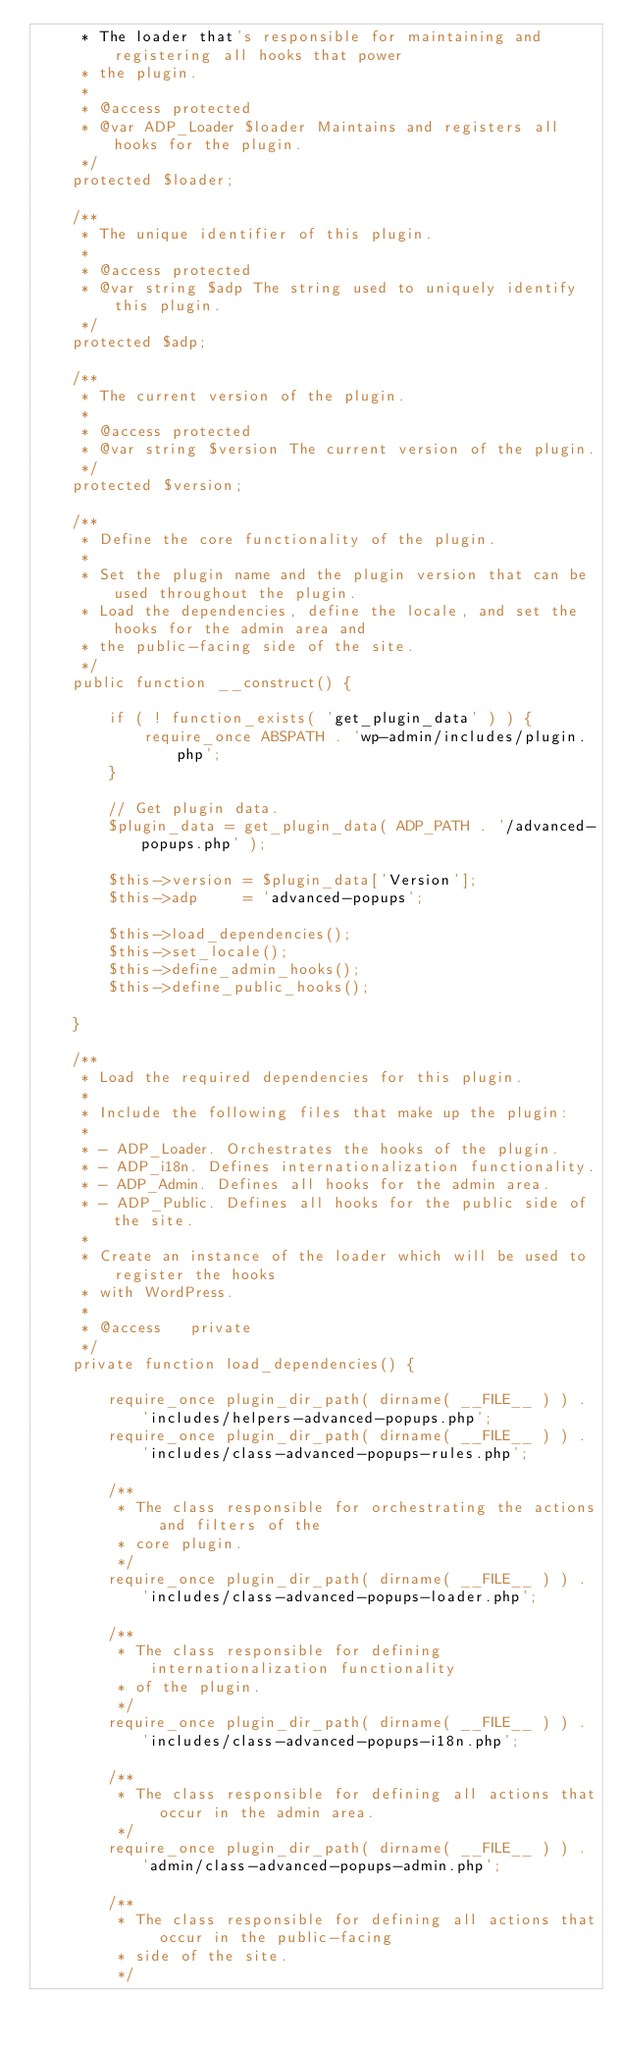Convert code to text. <code><loc_0><loc_0><loc_500><loc_500><_PHP_>	 * The loader that's responsible for maintaining and registering all hooks that power
	 * the plugin.
	 *
	 * @access protected
	 * @var ADP_Loader $loader Maintains and registers all hooks for the plugin.
	 */
	protected $loader;

	/**
	 * The unique identifier of this plugin.
	 *
	 * @access protected
	 * @var string $adp The string used to uniquely identify this plugin.
	 */
	protected $adp;

	/**
	 * The current version of the plugin.
	 *
	 * @access protected
	 * @var string $version The current version of the plugin.
	 */
	protected $version;

	/**
	 * Define the core functionality of the plugin.
	 *
	 * Set the plugin name and the plugin version that can be used throughout the plugin.
	 * Load the dependencies, define the locale, and set the hooks for the admin area and
	 * the public-facing side of the site.
	 */
	public function __construct() {

		if ( ! function_exists( 'get_plugin_data' ) ) {
			require_once ABSPATH . 'wp-admin/includes/plugin.php';
		}

		// Get plugin data.
		$plugin_data = get_plugin_data( ADP_PATH . '/advanced-popups.php' );

		$this->version = $plugin_data['Version'];
		$this->adp     = 'advanced-popups';

		$this->load_dependencies();
		$this->set_locale();
		$this->define_admin_hooks();
		$this->define_public_hooks();

	}

	/**
	 * Load the required dependencies for this plugin.
	 *
	 * Include the following files that make up the plugin:
	 *
	 * - ADP_Loader. Orchestrates the hooks of the plugin.
	 * - ADP_i18n. Defines internationalization functionality.
	 * - ADP_Admin. Defines all hooks for the admin area.
	 * - ADP_Public. Defines all hooks for the public side of the site.
	 *
	 * Create an instance of the loader which will be used to register the hooks
	 * with WordPress.
	 *
	 * @access   private
	 */
	private function load_dependencies() {

		require_once plugin_dir_path( dirname( __FILE__ ) ) . 'includes/helpers-advanced-popups.php';
		require_once plugin_dir_path( dirname( __FILE__ ) ) . 'includes/class-advanced-popups-rules.php';

		/**
		 * The class responsible for orchestrating the actions and filters of the
		 * core plugin.
		 */
		require_once plugin_dir_path( dirname( __FILE__ ) ) . 'includes/class-advanced-popups-loader.php';

		/**
		 * The class responsible for defining internationalization functionality
		 * of the plugin.
		 */
		require_once plugin_dir_path( dirname( __FILE__ ) ) . 'includes/class-advanced-popups-i18n.php';

		/**
		 * The class responsible for defining all actions that occur in the admin area.
		 */
		require_once plugin_dir_path( dirname( __FILE__ ) ) . 'admin/class-advanced-popups-admin.php';

		/**
		 * The class responsible for defining all actions that occur in the public-facing
		 * side of the site.
		 */</code> 